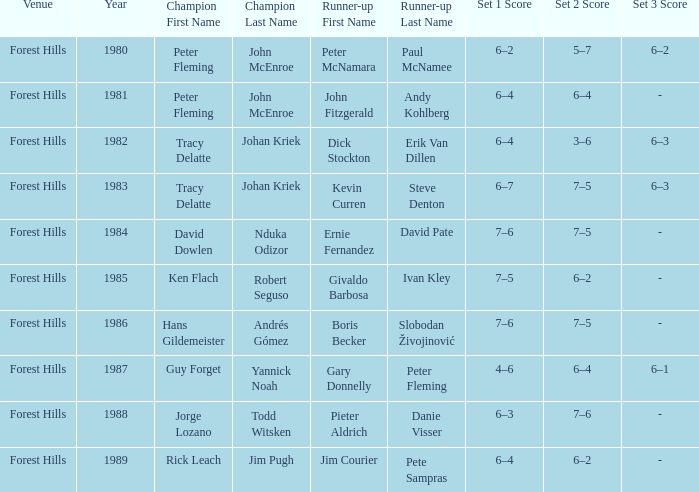Who was the runner-up in 1989? Jim Courier Pete Sampras. 